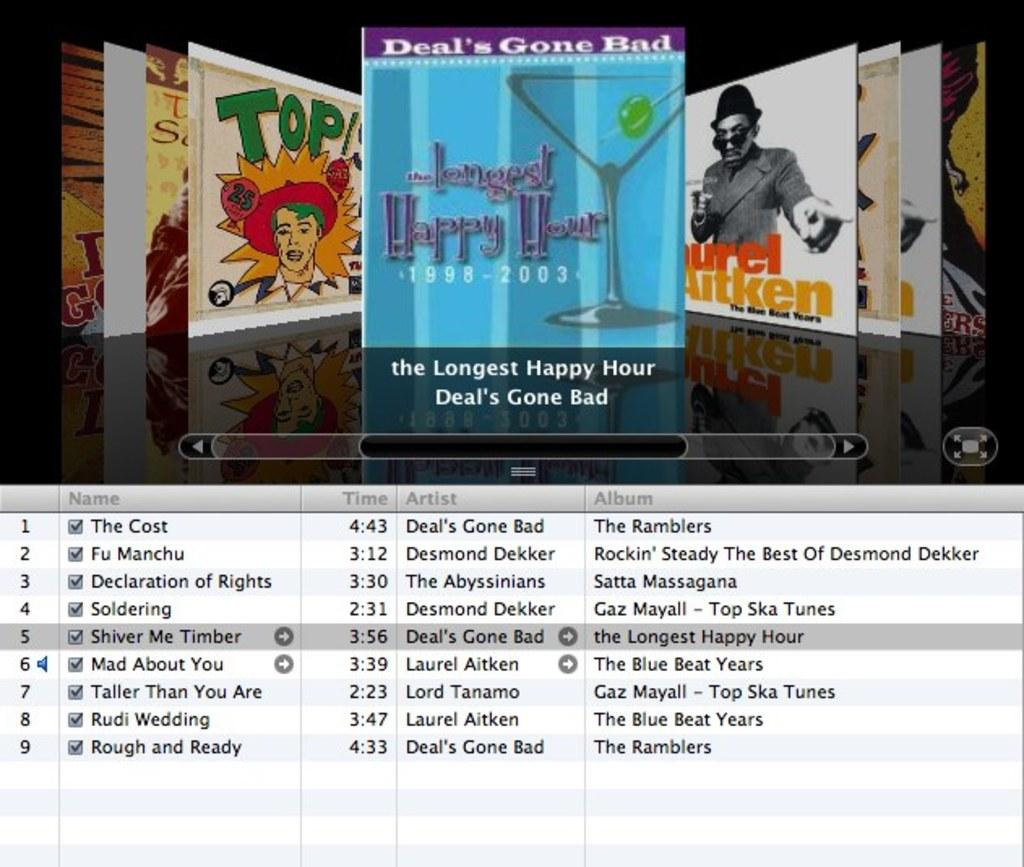What type of image is shown in the screenshot? The image contains a screenshot. Can you describe the person visible in the screenshot? There is a person visible in the screenshot. What kind of picture is present in the screenshot? There is a cartoon picture in the screenshot. What else can be seen in the screenshot besides the person and cartoon picture? There are objects present in the screenshot. Is there any text written on the screenshot? Yes, there is text written on the screenshot. What color is the background of the screenshot? The background of the screenshot is black. What type of yoke is being used by the person in the screenshot? There is no yoke present in the screenshot; it is a digital image with a person and cartoon picture. Can you describe the arch that is visible in the screenshot? There is no arch visible in the screenshot; it contains a person, cartoon picture, objects, text, and a black background. 